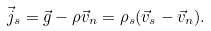<formula> <loc_0><loc_0><loc_500><loc_500>\vec { j } _ { s } = \vec { g } - \rho \vec { v } _ { n } = \rho _ { s } ( \vec { v } _ { s } - \vec { v } _ { n } ) .</formula> 